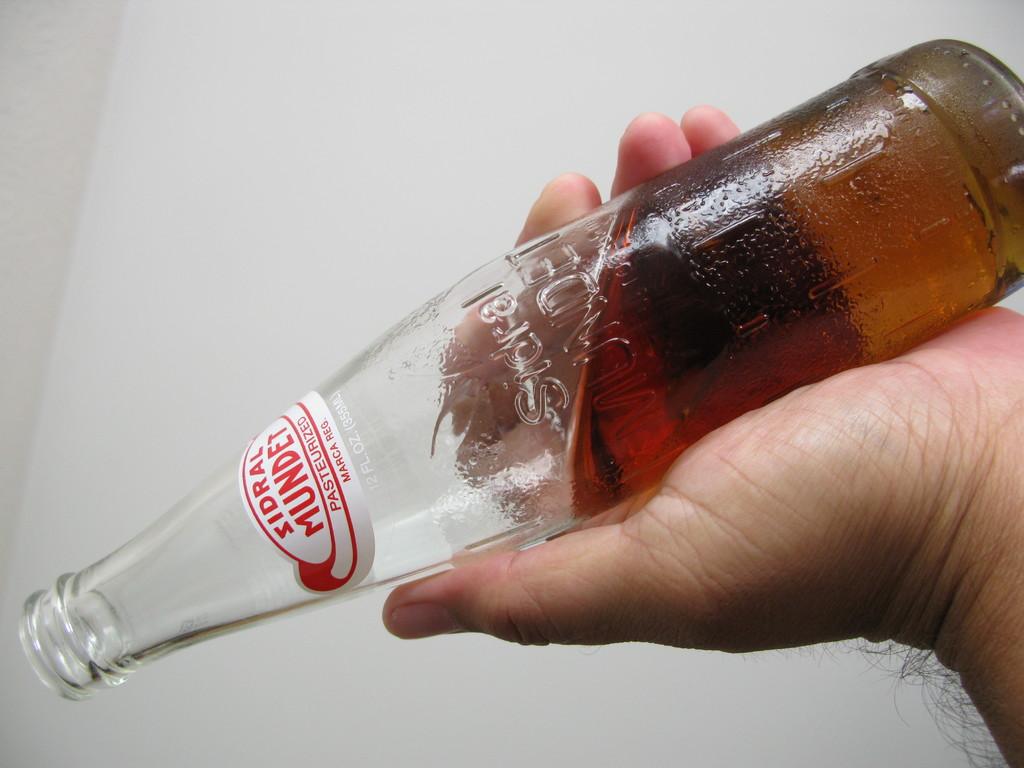What is the name of the cola?
Your response must be concise. Sidral mundet. How many ounces in the bottle?
Your answer should be very brief. Unanswerable. 